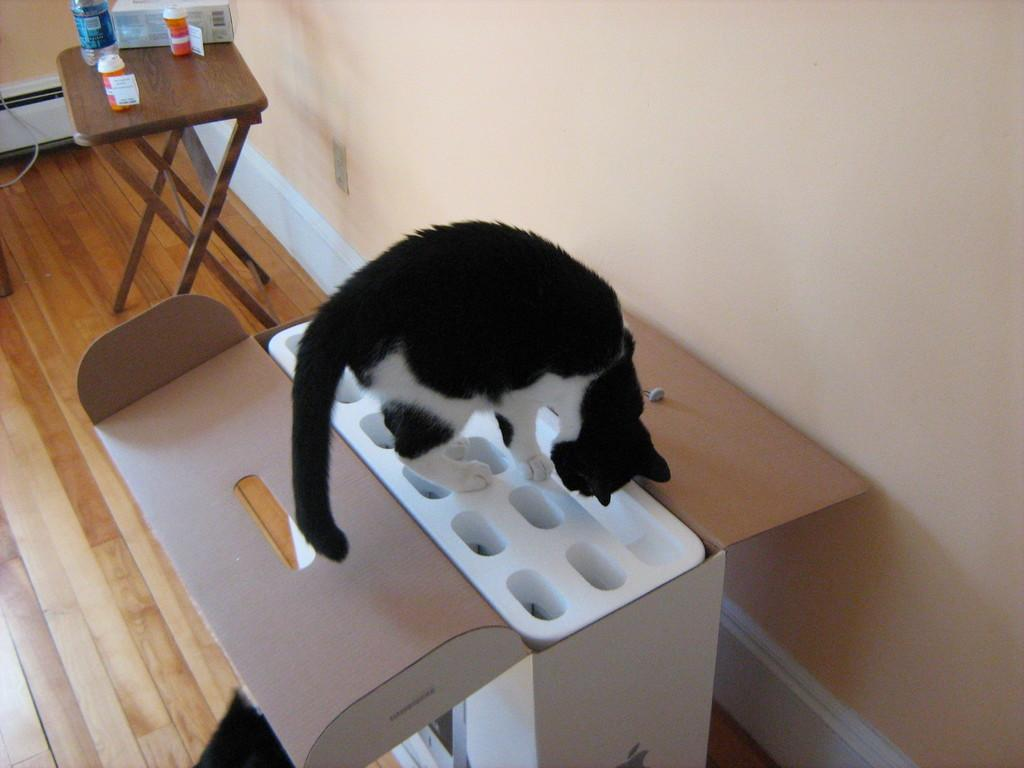What color is the floor in the image? The floor in the image is brown. What is the cat standing on? The cat is standing on a white object. What piece of furniture is present in the image? There is a table in the image. What is on the table? There is a bottle on the table. What can be seen in the background of the image? There is a wall visible in the image. How much income does the lake generate in the image? There is no lake present in the image, so it is not possible to determine its income. 